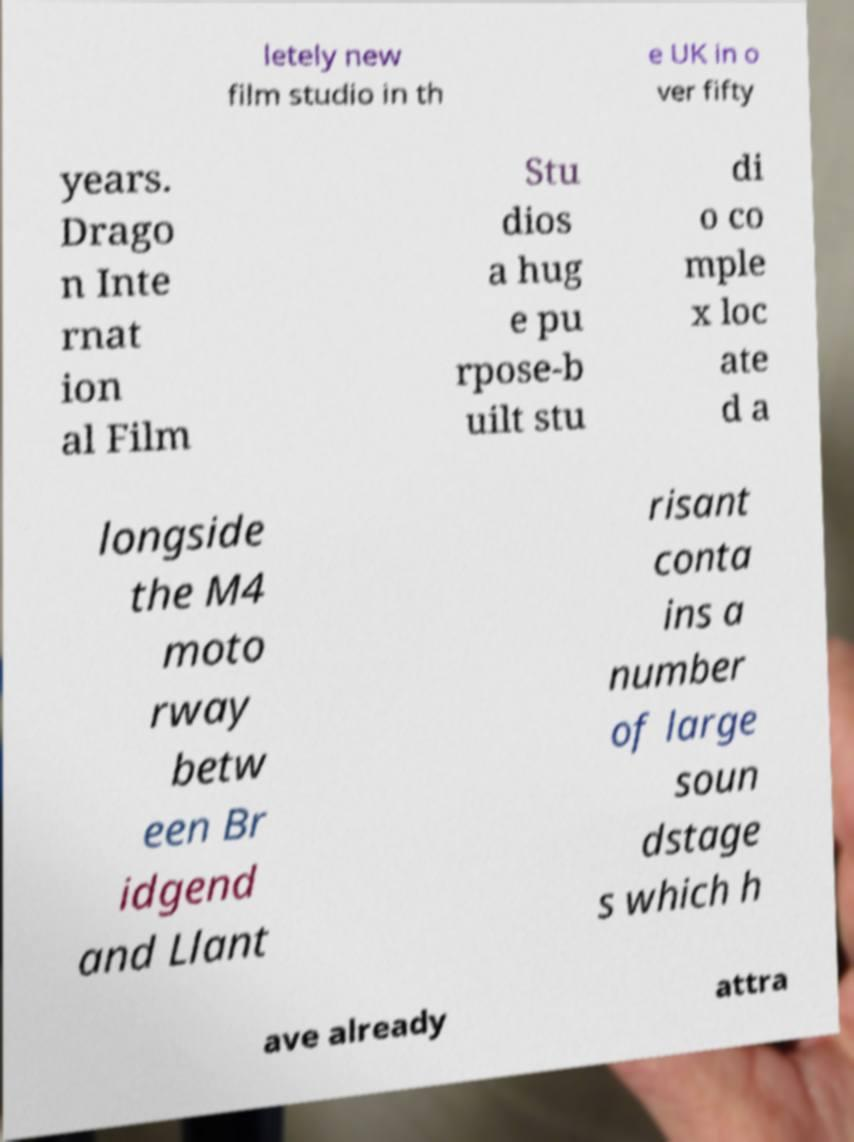Can you accurately transcribe the text from the provided image for me? letely new film studio in th e UK in o ver fifty years. Drago n Inte rnat ion al Film Stu dios a hug e pu rpose-b uilt stu di o co mple x loc ate d a longside the M4 moto rway betw een Br idgend and Llant risant conta ins a number of large soun dstage s which h ave already attra 